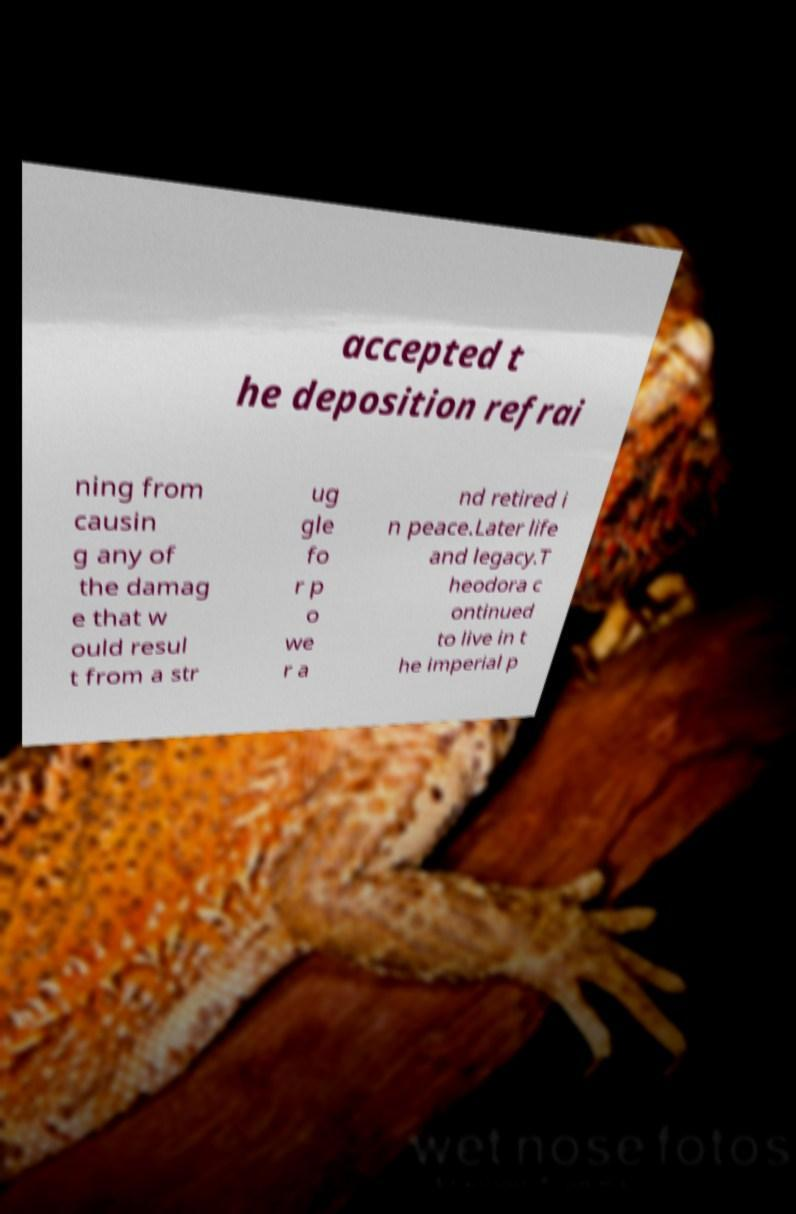Please identify and transcribe the text found in this image. accepted t he deposition refrai ning from causin g any of the damag e that w ould resul t from a str ug gle fo r p o we r a nd retired i n peace.Later life and legacy.T heodora c ontinued to live in t he imperial p 